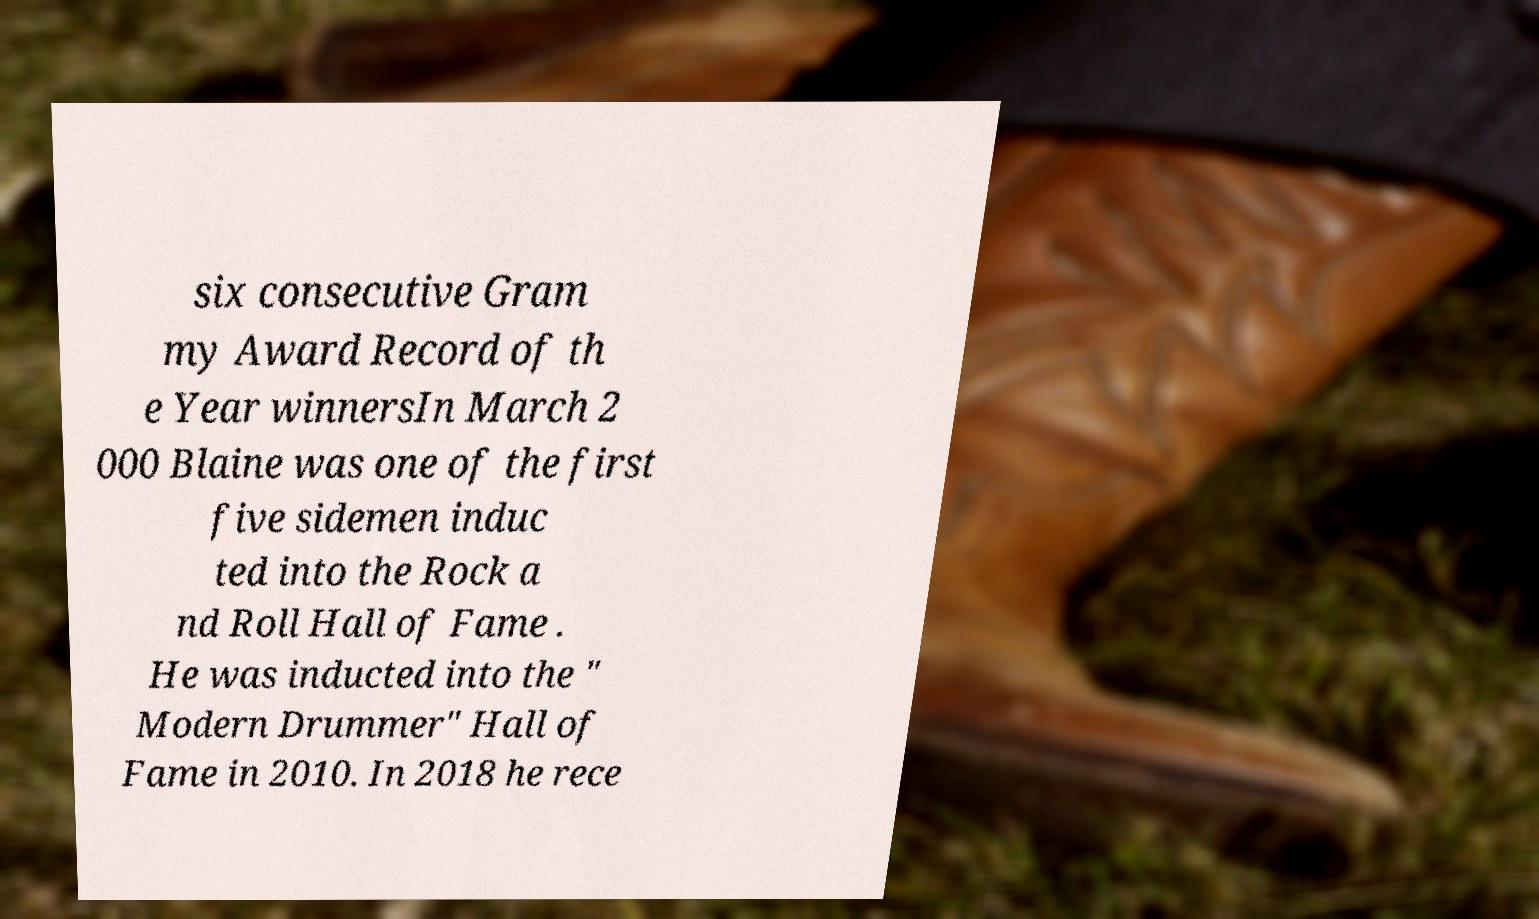For documentation purposes, I need the text within this image transcribed. Could you provide that? six consecutive Gram my Award Record of th e Year winnersIn March 2 000 Blaine was one of the first five sidemen induc ted into the Rock a nd Roll Hall of Fame . He was inducted into the " Modern Drummer" Hall of Fame in 2010. In 2018 he rece 